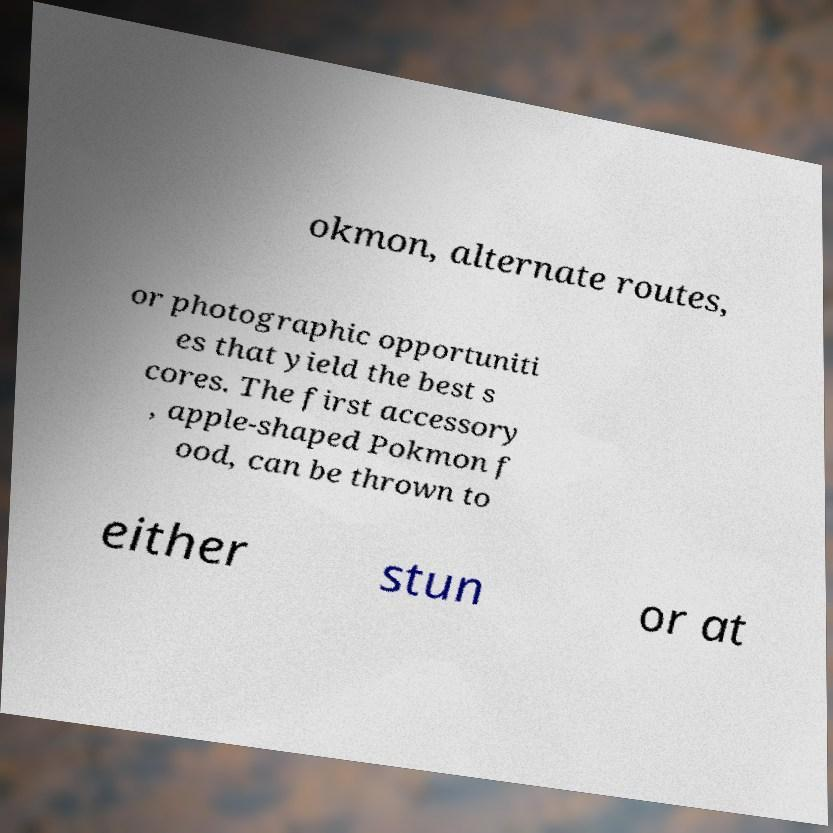For documentation purposes, I need the text within this image transcribed. Could you provide that? okmon, alternate routes, or photographic opportuniti es that yield the best s cores. The first accessory , apple-shaped Pokmon f ood, can be thrown to either stun or at 